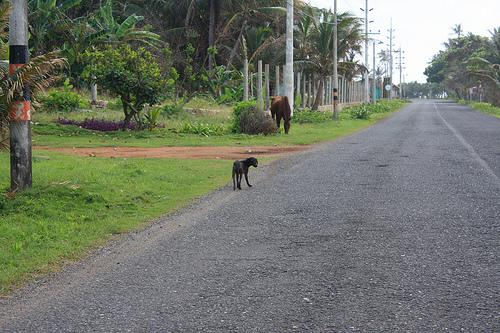Question: when was the photo taken?
Choices:
A. Morning.
B. Nightime.
C. Daytime.
D. At dinner.
Answer with the letter. Answer: C Question: what types are animal is shown on the black top?
Choices:
A. Cat.
B. Fish.
C. Snake.
D. Dog.
Answer with the letter. Answer: D Question: what type of animal is in the grass?
Choices:
A. Giraffe.
B. Rhino.
C. Elephant.
D. Horse.
Answer with the letter. Answer: D Question: what is the horse doing?
Choices:
A. Eating.
B. Running.
C. Trotting.
D. Gallaping.
Answer with the letter. Answer: A Question: what is on the right side of the road?
Choices:
A. A car.
B. Some bikes.
C. Trees.
D. Some people.
Answer with the letter. Answer: C Question: what is the white line?
Choices:
A. Hopscotch.
B. Chalk.
C. Paint.
D. Street.
Answer with the letter. Answer: D Question: where was the photo taken?
Choices:
A. On a street.
B. On a road.
C. On a highway.
D. On a railroad.
Answer with the letter. Answer: A 